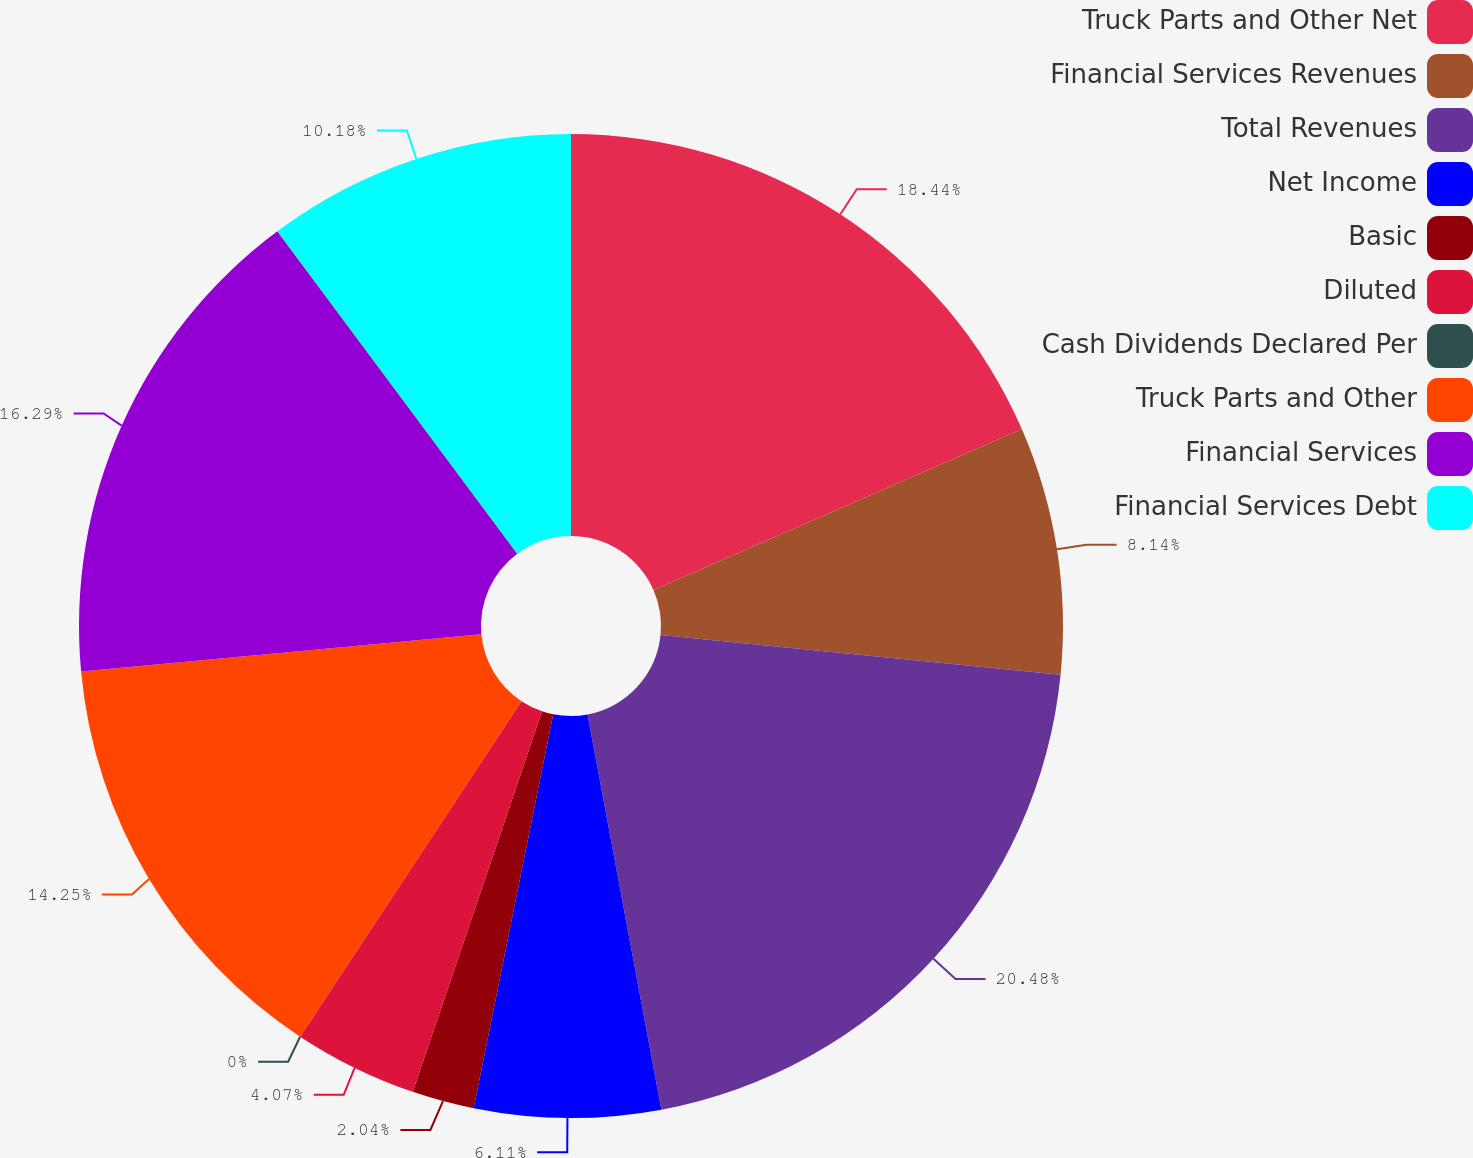Convert chart. <chart><loc_0><loc_0><loc_500><loc_500><pie_chart><fcel>Truck Parts and Other Net<fcel>Financial Services Revenues<fcel>Total Revenues<fcel>Net Income<fcel>Basic<fcel>Diluted<fcel>Cash Dividends Declared Per<fcel>Truck Parts and Other<fcel>Financial Services<fcel>Financial Services Debt<nl><fcel>18.44%<fcel>8.14%<fcel>20.48%<fcel>6.11%<fcel>2.04%<fcel>4.07%<fcel>0.0%<fcel>14.25%<fcel>16.29%<fcel>10.18%<nl></chart> 